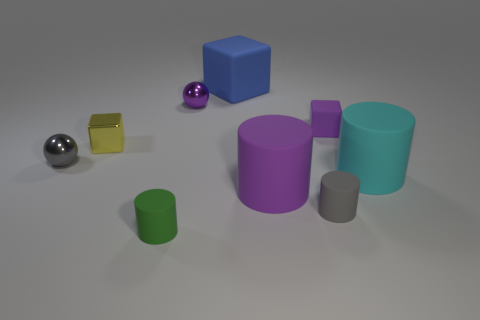Subtract all green cylinders. How many cylinders are left? 3 Subtract all brown cylinders. Subtract all purple spheres. How many cylinders are left? 4 Add 1 green matte cylinders. How many objects exist? 10 Subtract all blocks. How many objects are left? 6 Subtract all large red matte cubes. Subtract all matte blocks. How many objects are left? 7 Add 4 big cyan cylinders. How many big cyan cylinders are left? 5 Add 9 large red metallic cylinders. How many large red metallic cylinders exist? 9 Subtract 1 blue cubes. How many objects are left? 8 